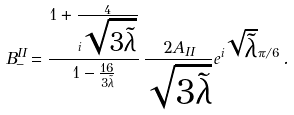Convert formula to latex. <formula><loc_0><loc_0><loc_500><loc_500>B _ { - } ^ { I I } = \frac { 1 + \frac { 4 } { i \sqrt { 3 \tilde { \lambda } } } } { 1 - \frac { 1 6 } { 3 \tilde { \lambda } } } \, \frac { 2 A _ { I I } } { \sqrt { 3 \tilde { \lambda } } } e ^ { i \sqrt { \tilde { \lambda } } \pi / 6 } \, .</formula> 